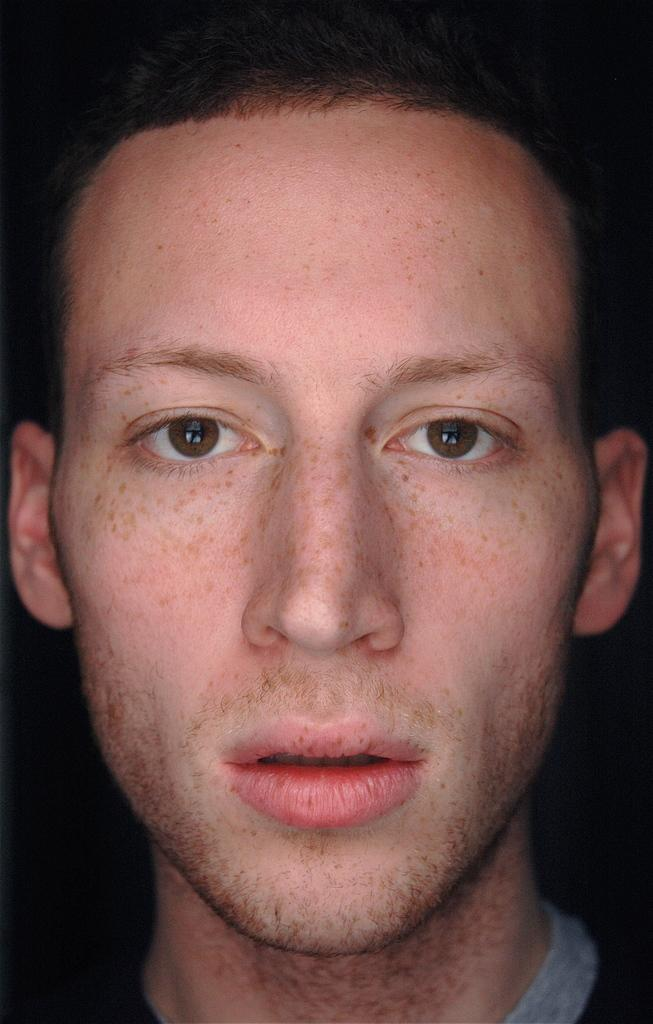What is the main subject of the image? There is a person in the image. Can you describe the setting of the image? The image may have been taken in a room or a similar setting. What type of lumber is the person using to balance in the image? There is no lumber present in the image, and the person is not shown balancing anything. 